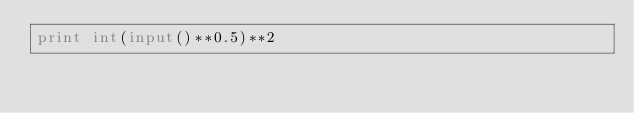Convert code to text. <code><loc_0><loc_0><loc_500><loc_500><_Python_>print int(input()**0.5)**2</code> 